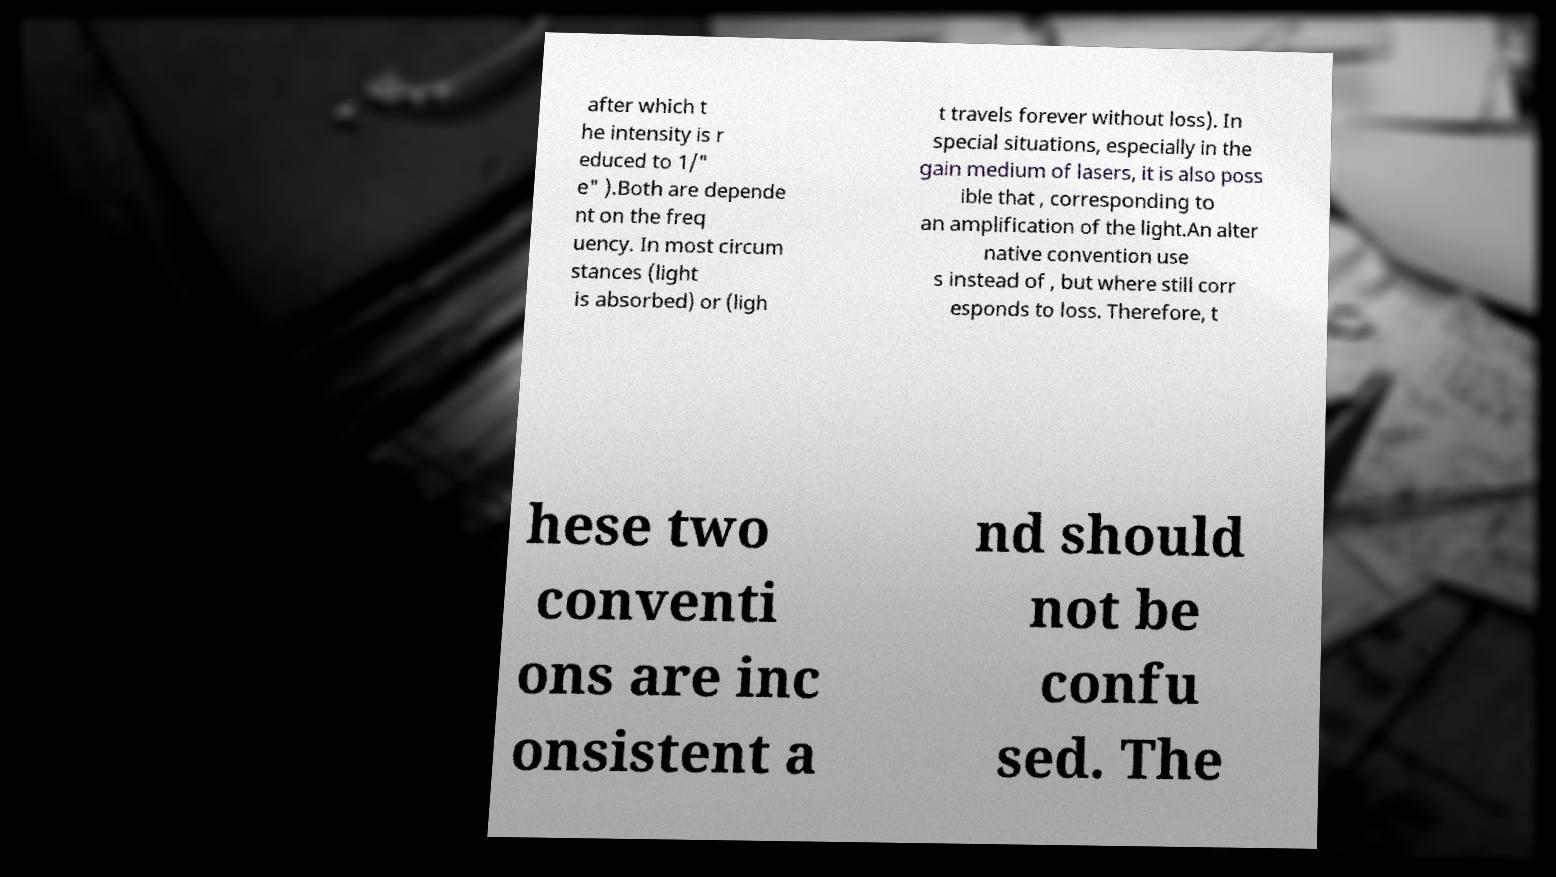Please read and relay the text visible in this image. What does it say? after which t he intensity is r educed to 1/" e" ).Both are depende nt on the freq uency. In most circum stances (light is absorbed) or (ligh t travels forever without loss). In special situations, especially in the gain medium of lasers, it is also poss ible that , corresponding to an amplification of the light.An alter native convention use s instead of , but where still corr esponds to loss. Therefore, t hese two conventi ons are inc onsistent a nd should not be confu sed. The 